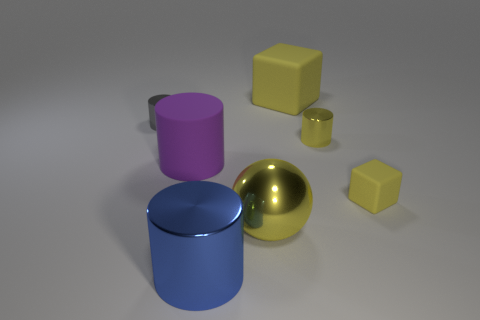What number of small objects are matte cubes or rubber objects?
Provide a short and direct response. 1. There is a large cylinder that is the same material as the large yellow cube; what color is it?
Your answer should be compact. Purple. There is a small metallic object that is in front of the small gray metal cylinder; is it the same shape as the small shiny object that is to the left of the big yellow cube?
Your answer should be compact. Yes. How many metal objects are either large red cylinders or balls?
Keep it short and to the point. 1. What is the material of the large object that is the same color as the big metal ball?
Provide a short and direct response. Rubber. Are there any other things that are the same shape as the tiny rubber thing?
Offer a very short reply. Yes. What is the material of the large object that is to the left of the large metal cylinder?
Your answer should be compact. Rubber. Are the small cylinder to the right of the blue cylinder and the tiny yellow block made of the same material?
Ensure brevity in your answer.  No. What number of things are shiny objects or large matte objects to the right of the big blue cylinder?
Your response must be concise. 5. What size is the other yellow thing that is the same shape as the small yellow matte thing?
Make the answer very short. Large. 